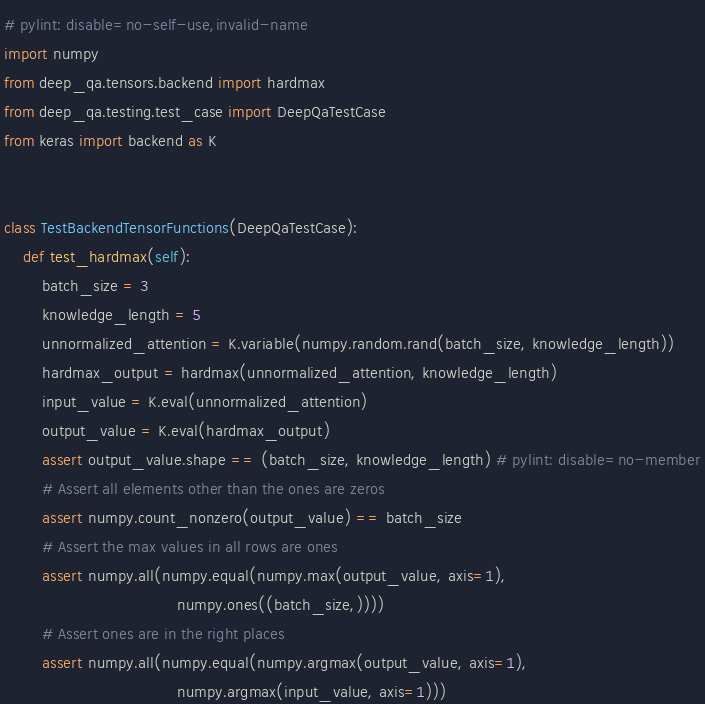Convert code to text. <code><loc_0><loc_0><loc_500><loc_500><_Python_># pylint: disable=no-self-use,invalid-name
import numpy
from deep_qa.tensors.backend import hardmax
from deep_qa.testing.test_case import DeepQaTestCase
from keras import backend as K


class TestBackendTensorFunctions(DeepQaTestCase):
    def test_hardmax(self):
        batch_size = 3
        knowledge_length = 5
        unnormalized_attention = K.variable(numpy.random.rand(batch_size, knowledge_length))
        hardmax_output = hardmax(unnormalized_attention, knowledge_length)
        input_value = K.eval(unnormalized_attention)
        output_value = K.eval(hardmax_output)
        assert output_value.shape == (batch_size, knowledge_length) # pylint: disable=no-member
        # Assert all elements other than the ones are zeros
        assert numpy.count_nonzero(output_value) == batch_size
        # Assert the max values in all rows are ones
        assert numpy.all(numpy.equal(numpy.max(output_value, axis=1),
                                     numpy.ones((batch_size,))))
        # Assert ones are in the right places
        assert numpy.all(numpy.equal(numpy.argmax(output_value, axis=1),
                                     numpy.argmax(input_value, axis=1)))
</code> 